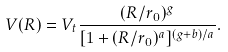Convert formula to latex. <formula><loc_0><loc_0><loc_500><loc_500>V ( R ) = V _ { t } \frac { ( R / r _ { 0 } ) ^ { g } } { [ 1 + ( R / r _ { 0 } ) ^ { a } ] ^ { ( g + b ) / a } } .</formula> 